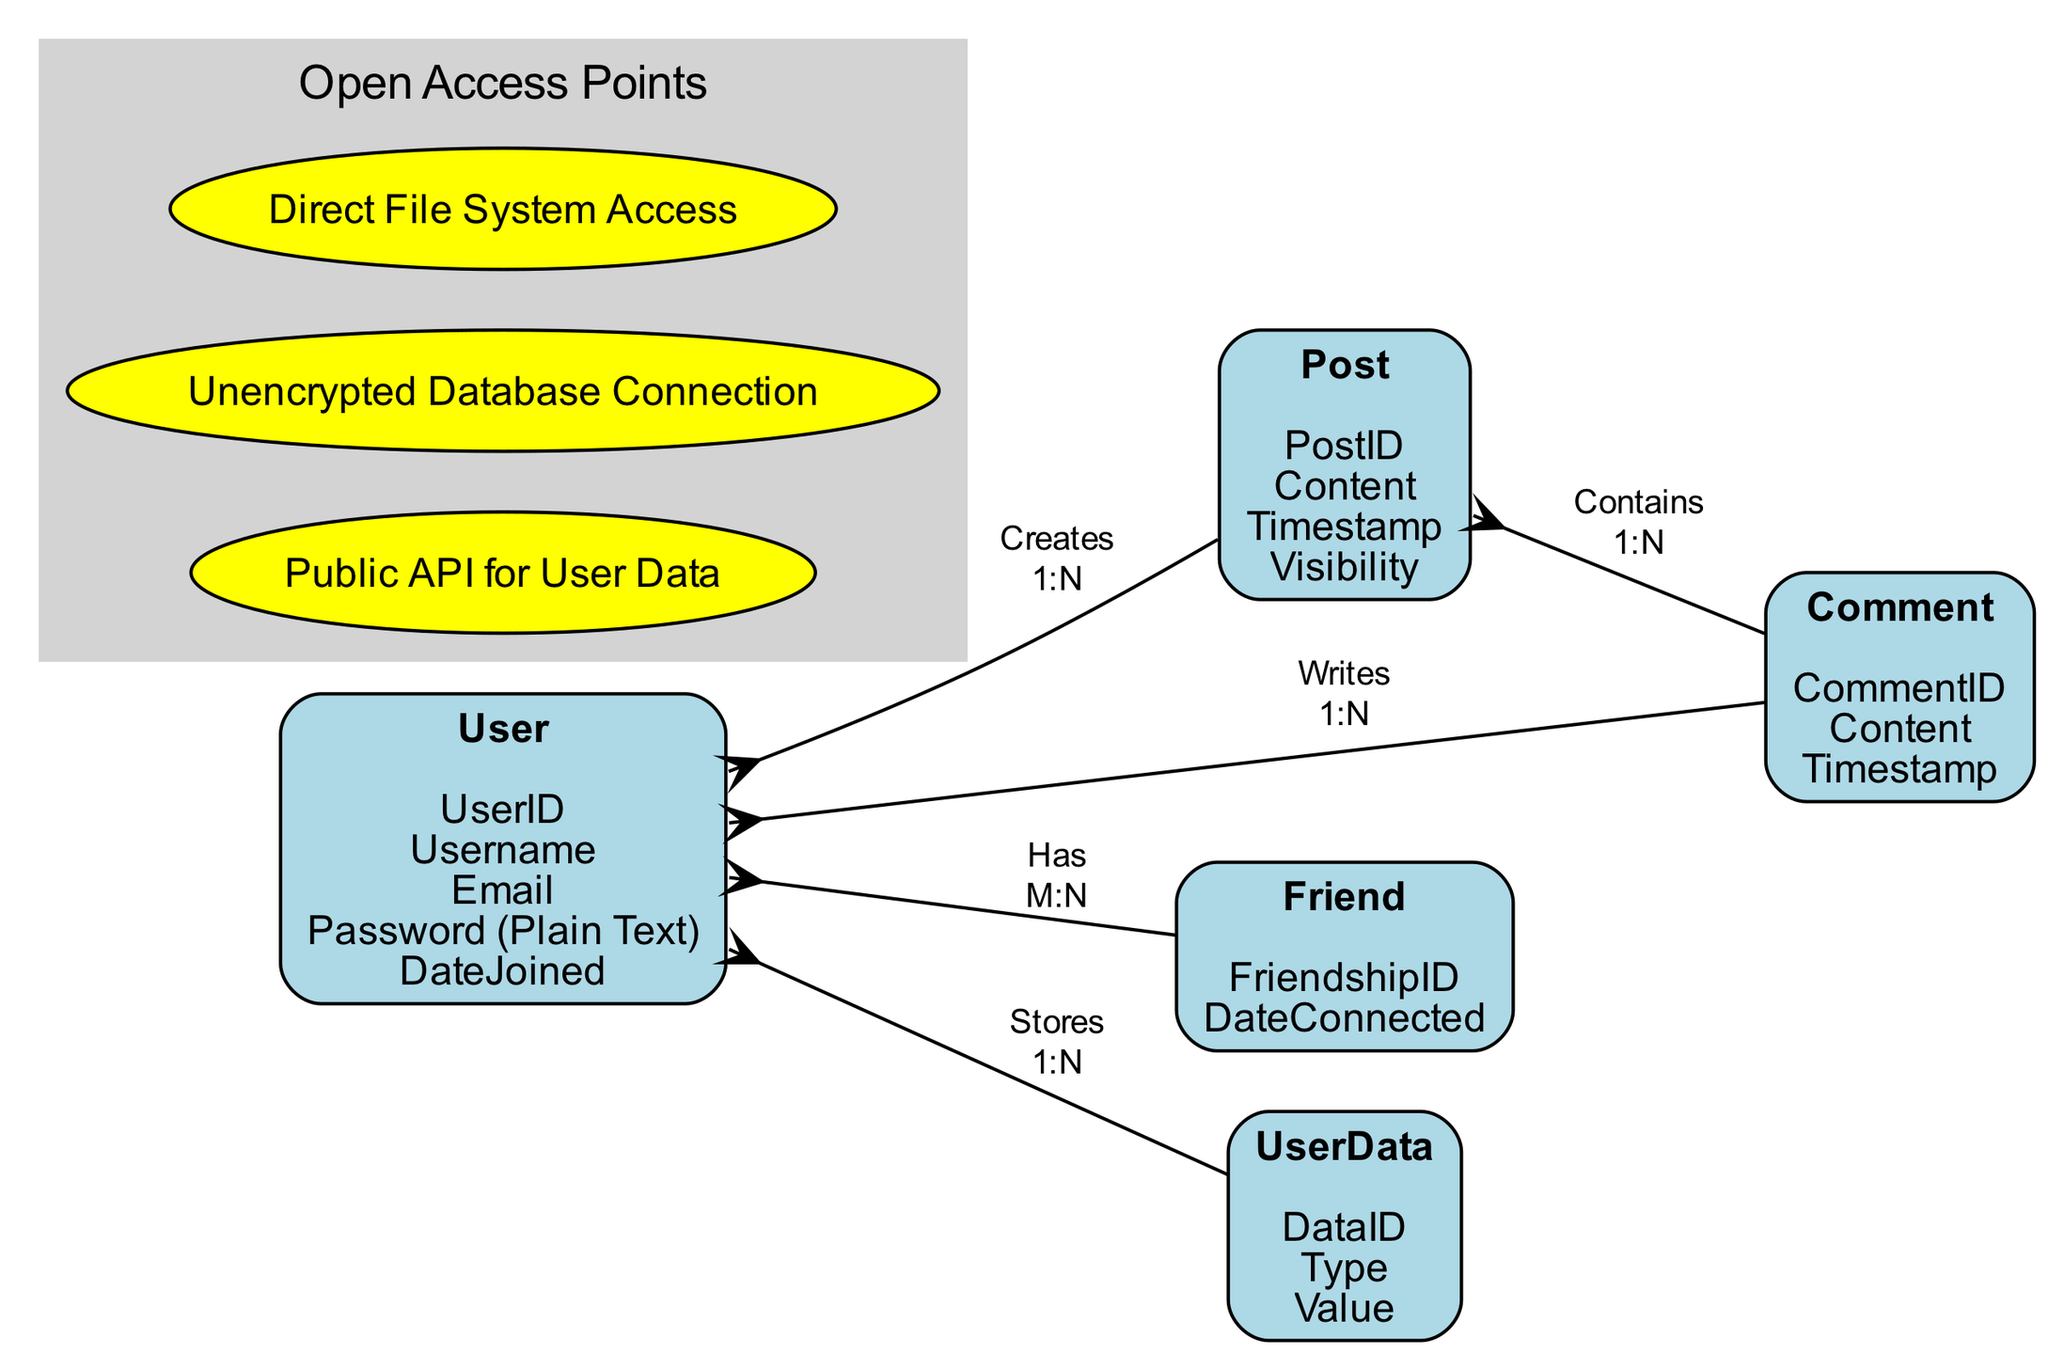What is the primary identifier for a User entity? The primary identifier for a User entity is denoted as "UserID". This information is directly provided in the attributes of the User node in the diagram.
Answer: UserID How many attributes does the Post entity have? The Post entity contains four attributes: PostID, Content, Timestamp, and Visibility. This count can be easily observed by listing the attributes in the Post node.
Answer: 4 What kind of relationship exists between User and Friend entities? The relationship between User and Friend entities is labeled as "Has" and depicted as a many-to-many (M:N) relationship. This can be derived from the relationships section connecting these two nodes.
Answer: M:N Which entity writes comments? The entity that writes comments is the User. This is indicated by the relationship labeled "Writes" that connects User to Comment, showing that users can write multiple comments.
Answer: User How many open access points are listed in the diagram? There are three open access points highlighted in the diagram, which include Public API for User Data, Unencrypted Database Connection, and Direct File System Access. This number is counted directly from the open access points section.
Answer: 3 What is the relationship type between Post and Comment entities? The relationship type between Post and Comment entities is defined as "Contains" and is classified as one-to-many (1:N). This detail can be understood by analyzing the connection and its label in the diagram.
Answer: 1:N Which entity has a direct relationship to UserData? The entity with a direct relationship to UserData is the User, as indicated by the relationship labeled "Stores" connecting these two entities. By tracing the arrows, we can confirm this connection.
Answer: User In what year the user data was joined according to the attributes? The DateJoined attribute specifies the year when a user data was joined, however, this is contingent upon actual data entries not provided in the diagram. Thus, this question requires additional context to be answered definitively.
Answer: Unknown 